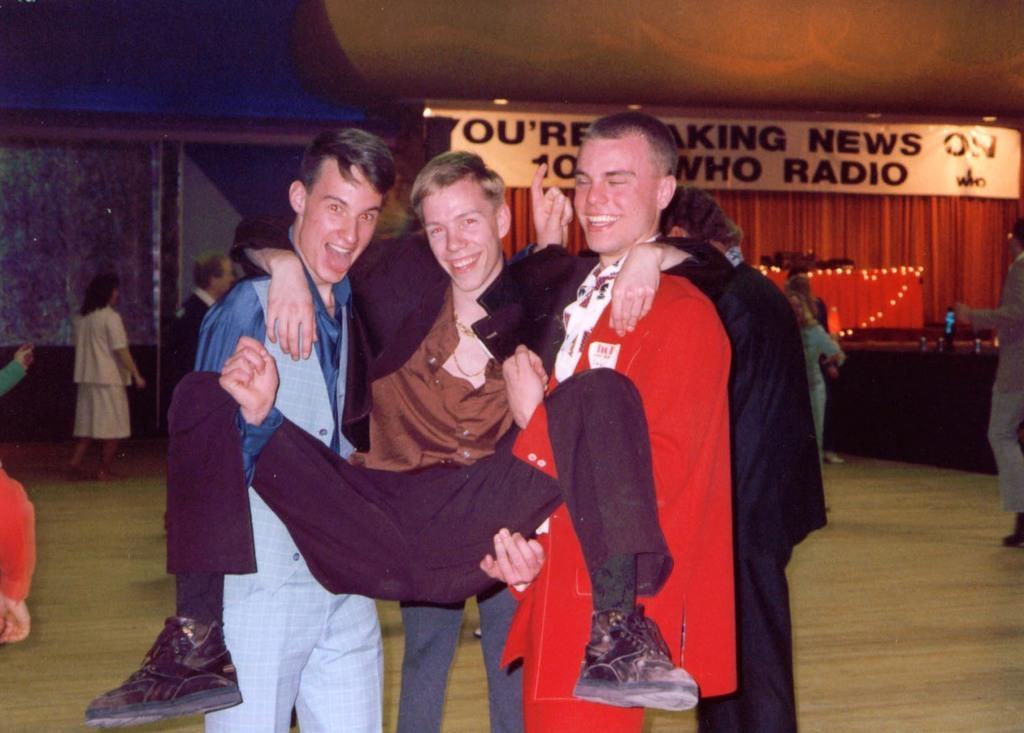In one or two sentences, can you explain what this image depicts? In this picture there are boys in the center of the image and there are other people in the background area of the image and there is a flex at the top side of the image. 